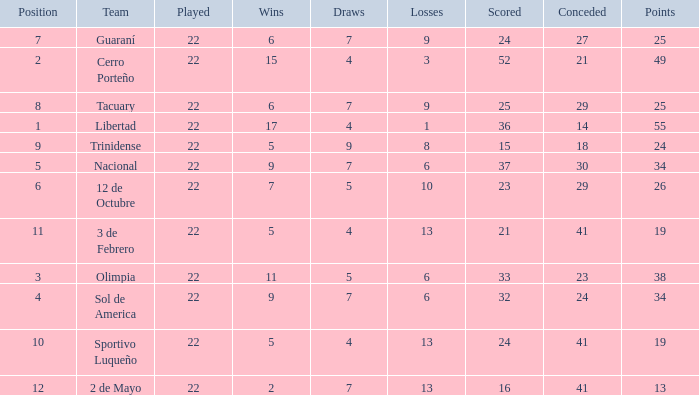What is the number of draws for the team with more than 8 losses and 13 points? 7.0. 